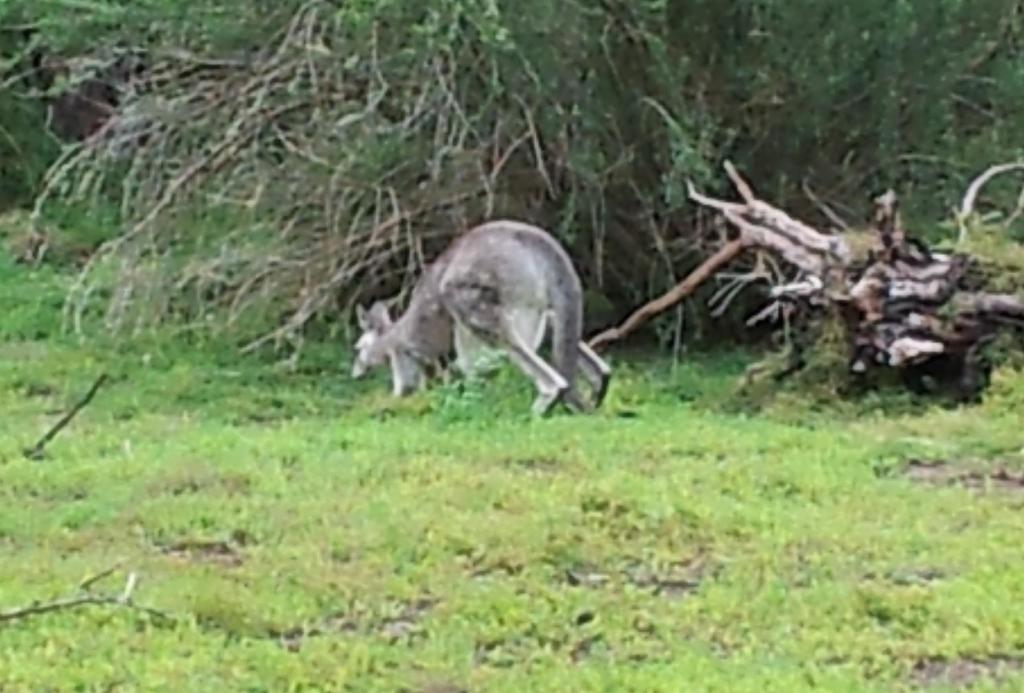What can be seen on the ground in the image? The ground is visible in the image, and there is grass on the ground. What type of vegetation is present on the ground? There is grass on the ground in the image. Can you describe the animal in the image? The animal in the image is black and cream in color. What is visible in the background of the image? There are trees in the background of the image. What type of sign can be seen in the image? There is no sign present in the image. How does the animal react to the presence of the trees in the image? The image does not show the animal's reaction to the trees, as it only depicts the animal and the trees separately. 